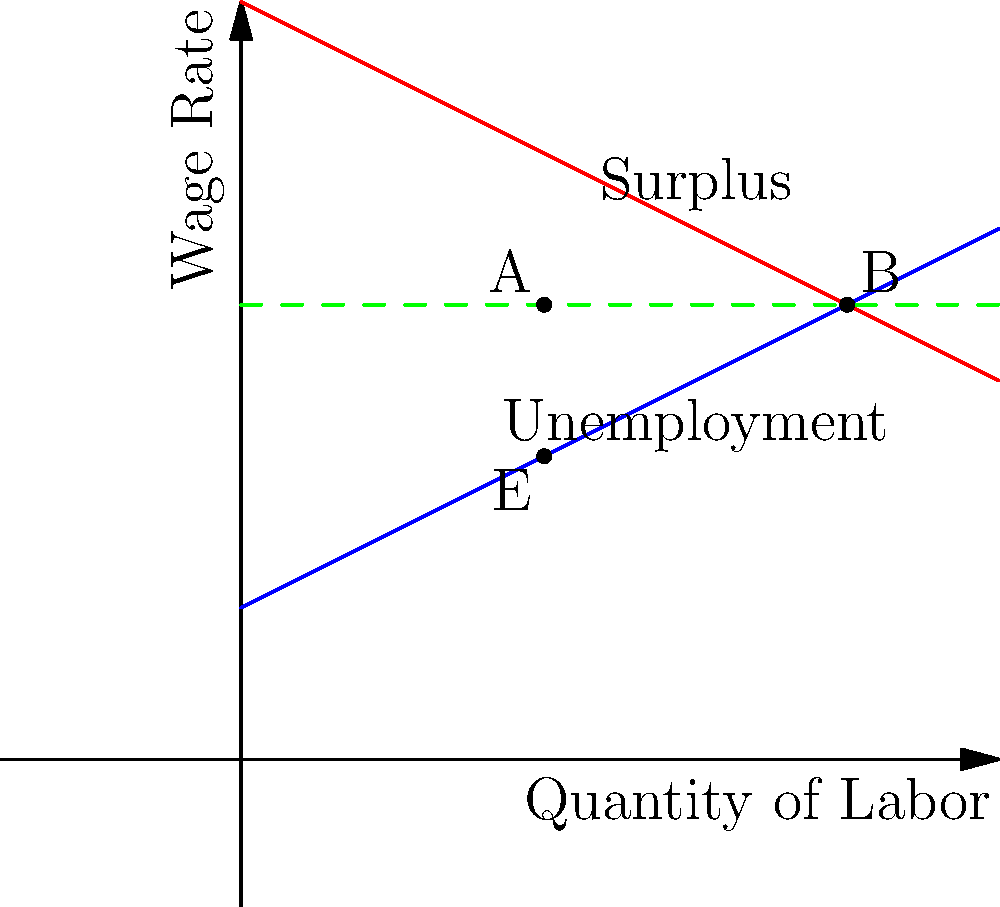As the Minister of Finance, you are analyzing the impact of a minimum wage increase on employment. The graph shows the labor market's supply and demand curves before and after the implementation of a minimum wage. The original equilibrium point is at E, and the new minimum wage is set at the green dashed line.

Calculate the unemployment rate resulting from this minimum wage increase, expressed as a percentage of the original employment level. Round your answer to the nearest whole percentage. To solve this problem, we'll follow these steps:

1. Identify the original equilibrium point (E):
   The supply and demand curves intersect at point E, which represents (4, 4).
   This means the original employment level is 4 units.

2. Identify the new employment level after minimum wage implementation:
   The minimum wage line intersects the demand curve at point A, which is at (4, 6).
   This means the new employment level is 4 units.

3. Identify the labor supply at the new minimum wage:
   The minimum wage line intersects the supply curve at point B, which is at (8, 6).
   This means 8 units of labor are willing to work at the new minimum wage.

4. Calculate the unemployment:
   Unemployment = Labor supply - Employment
   Unemployment = 8 - 4 = 4 units

5. Calculate the unemployment rate:
   Unemployment rate = (Unemployment / Original employment) * 100%
   Unemployment rate = (4 / 4) * 100% = 100%

Therefore, the unemployment rate resulting from this minimum wage increase is 100% of the original employment level.
Answer: 100% 